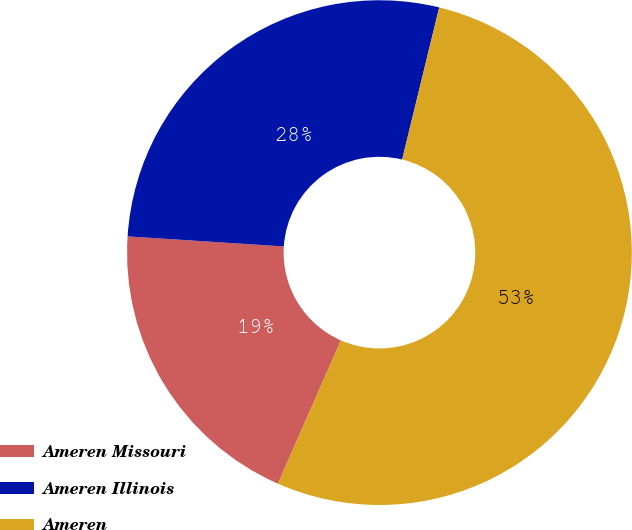Convert chart to OTSL. <chart><loc_0><loc_0><loc_500><loc_500><pie_chart><fcel>Ameren Missouri<fcel>Ameren Illinois<fcel>Ameren<nl><fcel>19.44%<fcel>27.78%<fcel>52.78%<nl></chart> 